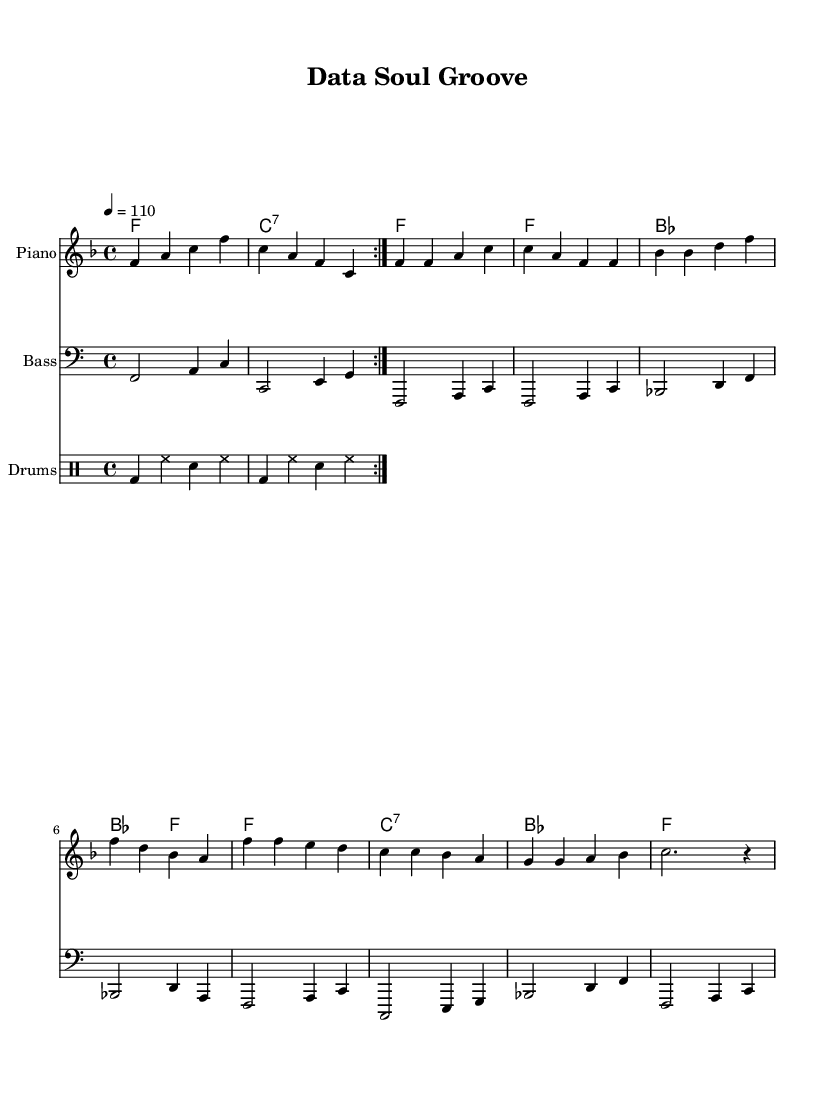What is the key signature of this music? The key signature is F major, indicated by one flat. This can be determined by looking at the beginning of the sheet music where the key signature is marked.
Answer: F major What is the time signature of this music? The time signature is 4/4, which means there are four beats in each measure and the quarter note gets one beat. This is shown at the beginning of the sheet music right after the key signature.
Answer: 4/4 What is the tempo marking of this piece? The tempo marking is 110 beats per minute, indicated at the start of the song, typically represented as "4 = 110." This shows the speed of the music.
Answer: 110 How many measures are in the verse section? The verse section consists of four measures; this can be counted by identifying the measure lines within the verse section of the sheet music.
Answer: 4 Which chord is played in the chorus? The primary chord played in the chorus is F major, which is the first chord listed in the harmonies section of the sheet music during the chorus.
Answer: F What type of rhythm pattern does the drum part utilize? The drum part utilizes a basic rock pattern with a bass drum, hi-hat, and snare, repeated twice. This can be interpreted by looking at the drummode representation indicating the use of these components.
Answer: Basic rock pattern What is the structure of this music in terms of sections? The structure consists of an intro, verse, and chorus, clearly outlined by the way the melody and harmonies are organized within the sheet music.
Answer: Intro, Verse, Chorus 